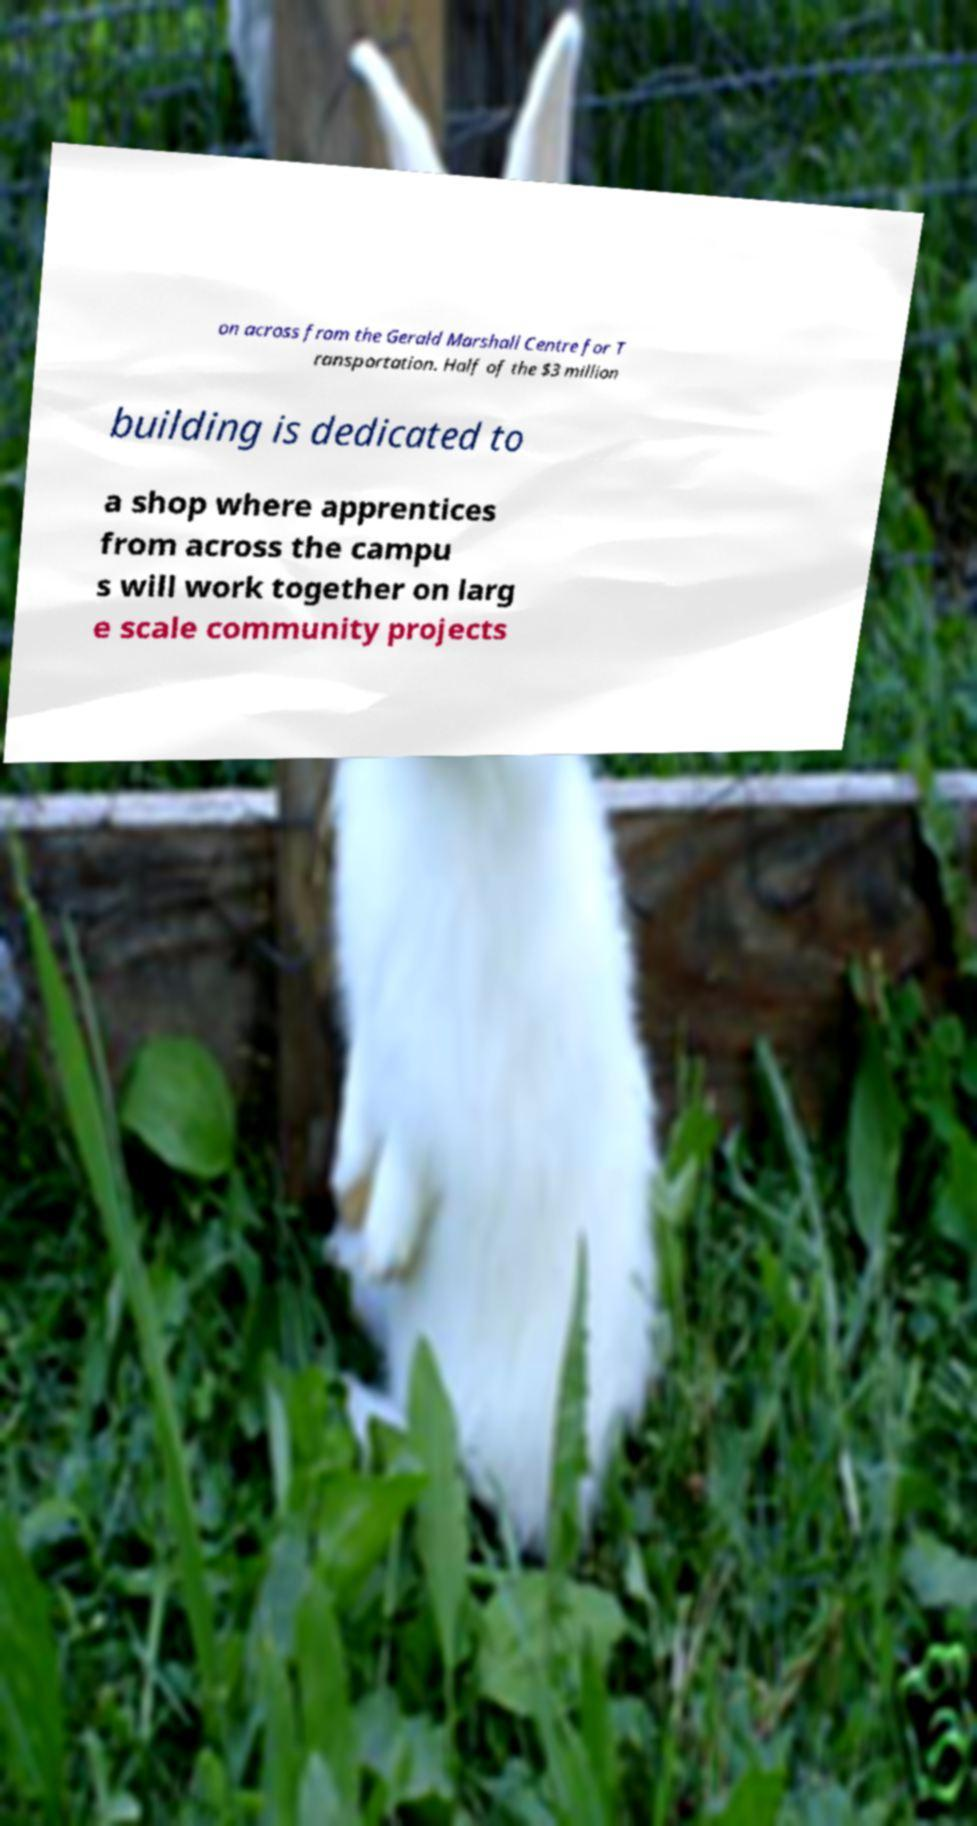Please read and relay the text visible in this image. What does it say? on across from the Gerald Marshall Centre for T ransportation. Half of the $3 million building is dedicated to a shop where apprentices from across the campu s will work together on larg e scale community projects 